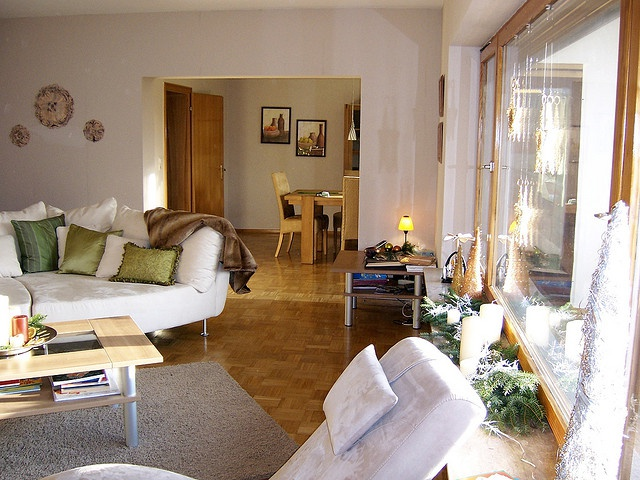Describe the objects in this image and their specific colors. I can see couch in gray, lightgray, darkgray, olive, and tan tones, couch in gray, darkgray, lavender, and lightgray tones, potted plant in gray, white, black, and darkgreen tones, chair in gray, maroon, black, tan, and olive tones, and dining table in gray, olive, black, and maroon tones in this image. 